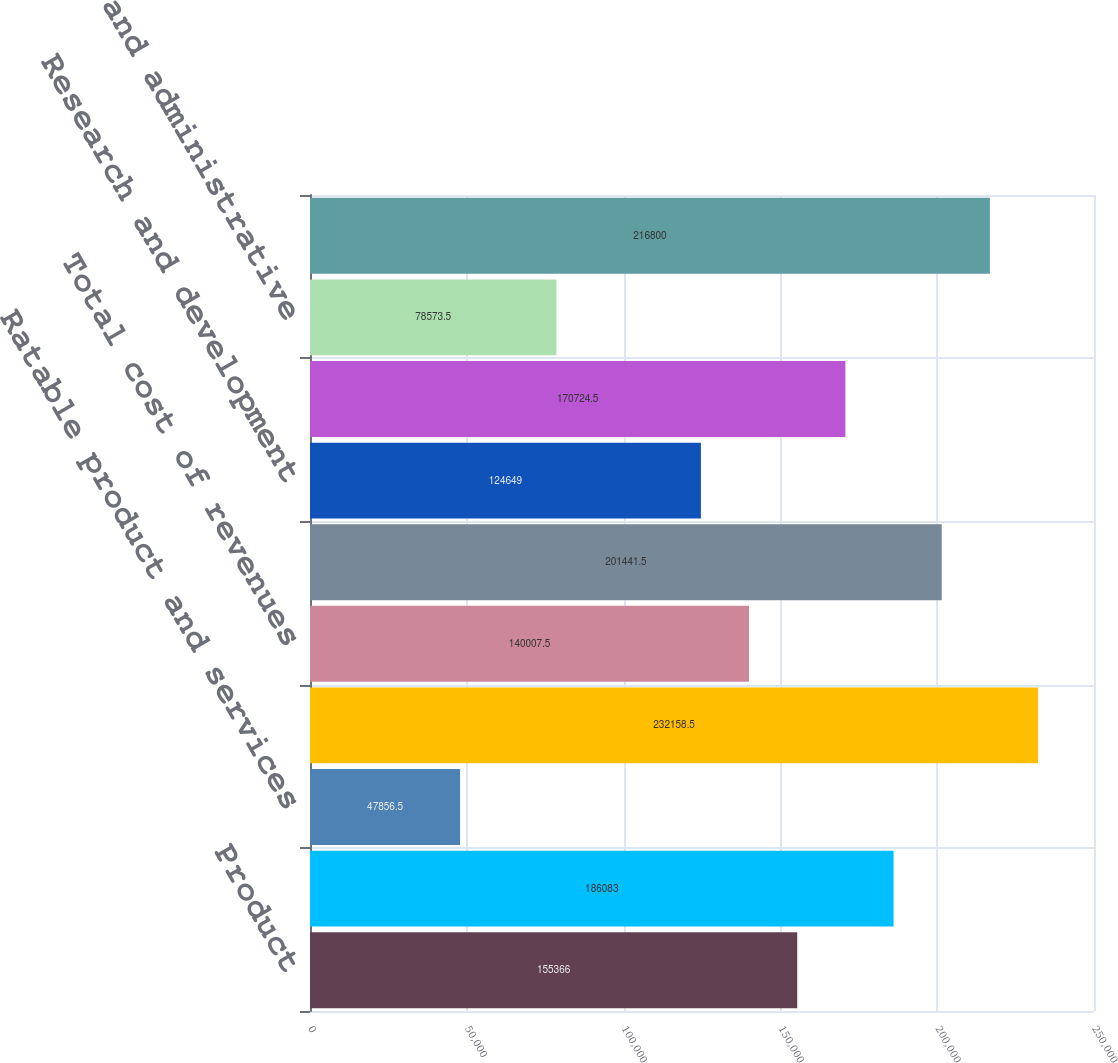Convert chart to OTSL. <chart><loc_0><loc_0><loc_500><loc_500><bar_chart><fcel>Product<fcel>Services<fcel>Ratable product and services<fcel>Total revenue<fcel>Total cost of revenues<fcel>Total gross profit<fcel>Research and development<fcel>Sales and marketing<fcel>General and administrative<fcel>Total operating expenses<nl><fcel>155366<fcel>186083<fcel>47856.5<fcel>232158<fcel>140008<fcel>201442<fcel>124649<fcel>170724<fcel>78573.5<fcel>216800<nl></chart> 